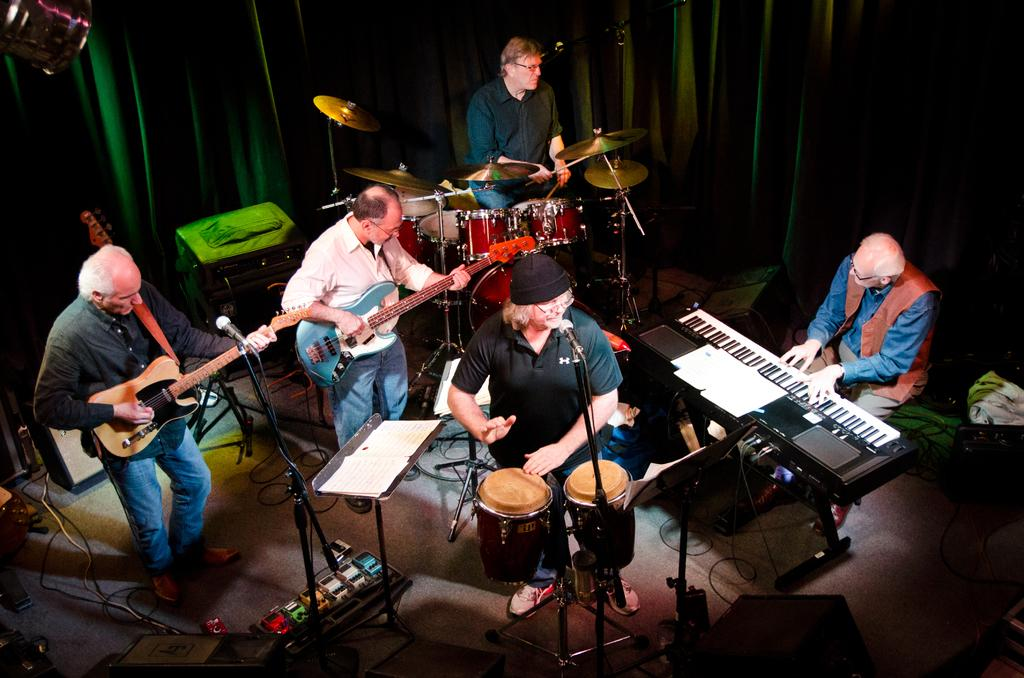Where was the image taken? The image was taken on a stage. What are the people in the image doing? The people are playing different music instruments. What can be seen in the background of the image? There is a green curtain in the background. What is visible at the top of the image? There are lights visible at the top of the image. What type of condition does the cow have in the image? There is no cow present in the image. How many apples are being eaten by the people in the image? There are no apples visible in the image; the people are playing music instruments. 